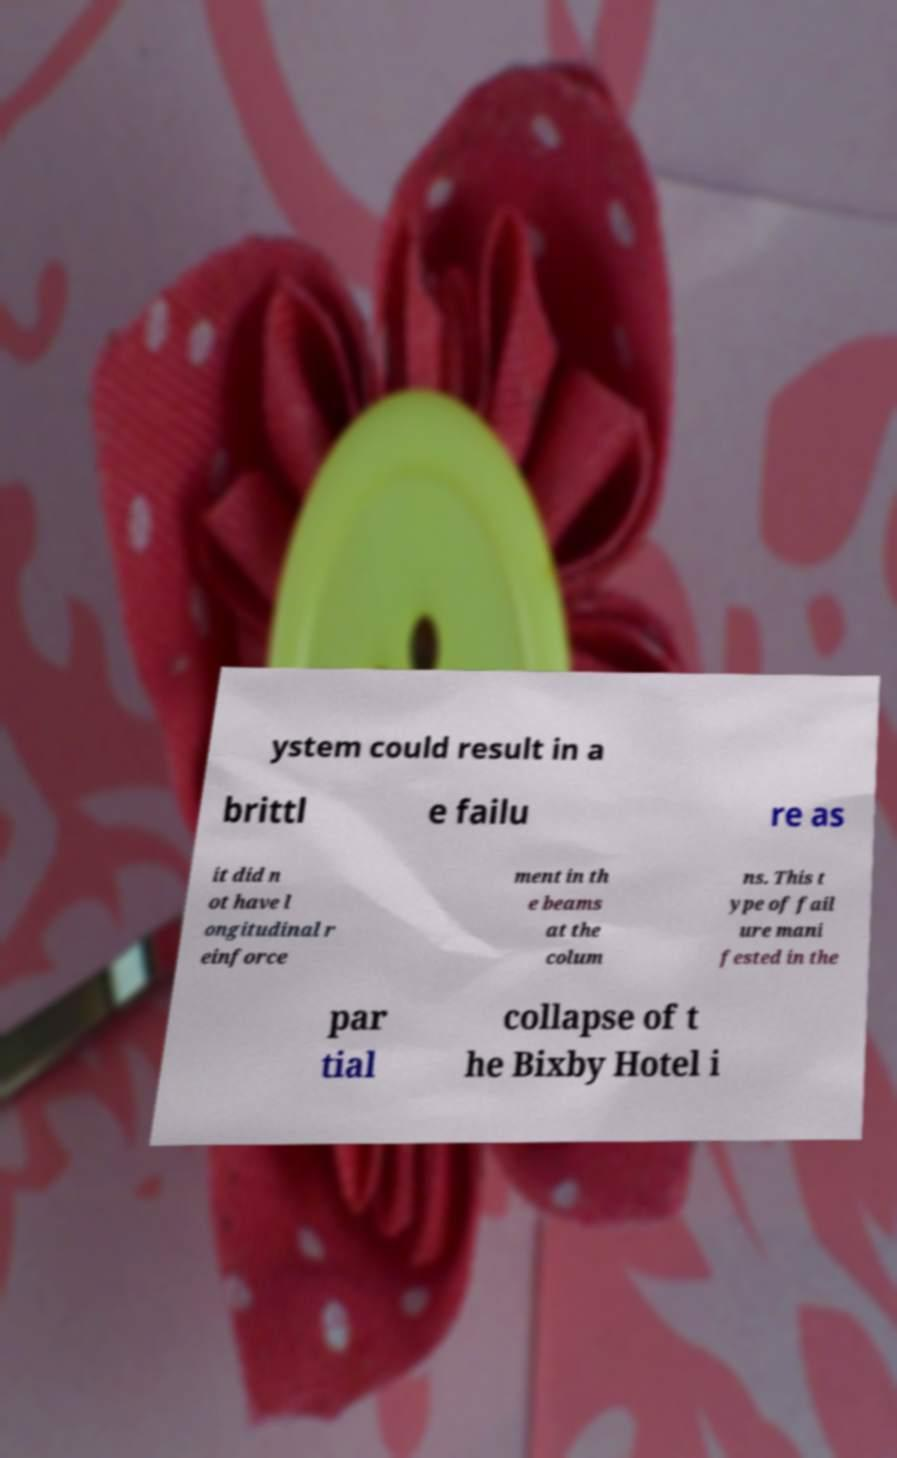What messages or text are displayed in this image? I need them in a readable, typed format. ystem could result in a brittl e failu re as it did n ot have l ongitudinal r einforce ment in th e beams at the colum ns. This t ype of fail ure mani fested in the par tial collapse of t he Bixby Hotel i 